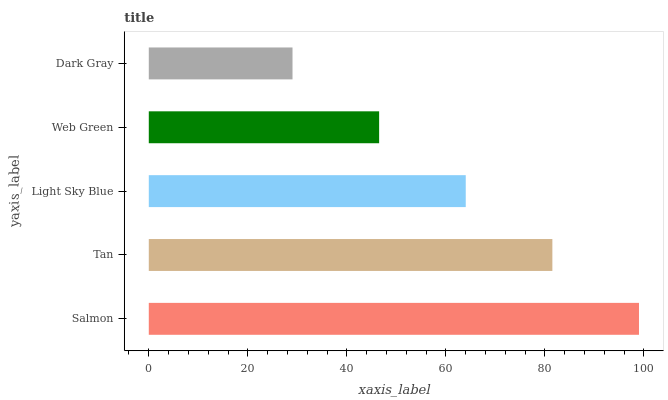Is Dark Gray the minimum?
Answer yes or no. Yes. Is Salmon the maximum?
Answer yes or no. Yes. Is Tan the minimum?
Answer yes or no. No. Is Tan the maximum?
Answer yes or no. No. Is Salmon greater than Tan?
Answer yes or no. Yes. Is Tan less than Salmon?
Answer yes or no. Yes. Is Tan greater than Salmon?
Answer yes or no. No. Is Salmon less than Tan?
Answer yes or no. No. Is Light Sky Blue the high median?
Answer yes or no. Yes. Is Light Sky Blue the low median?
Answer yes or no. Yes. Is Tan the high median?
Answer yes or no. No. Is Dark Gray the low median?
Answer yes or no. No. 